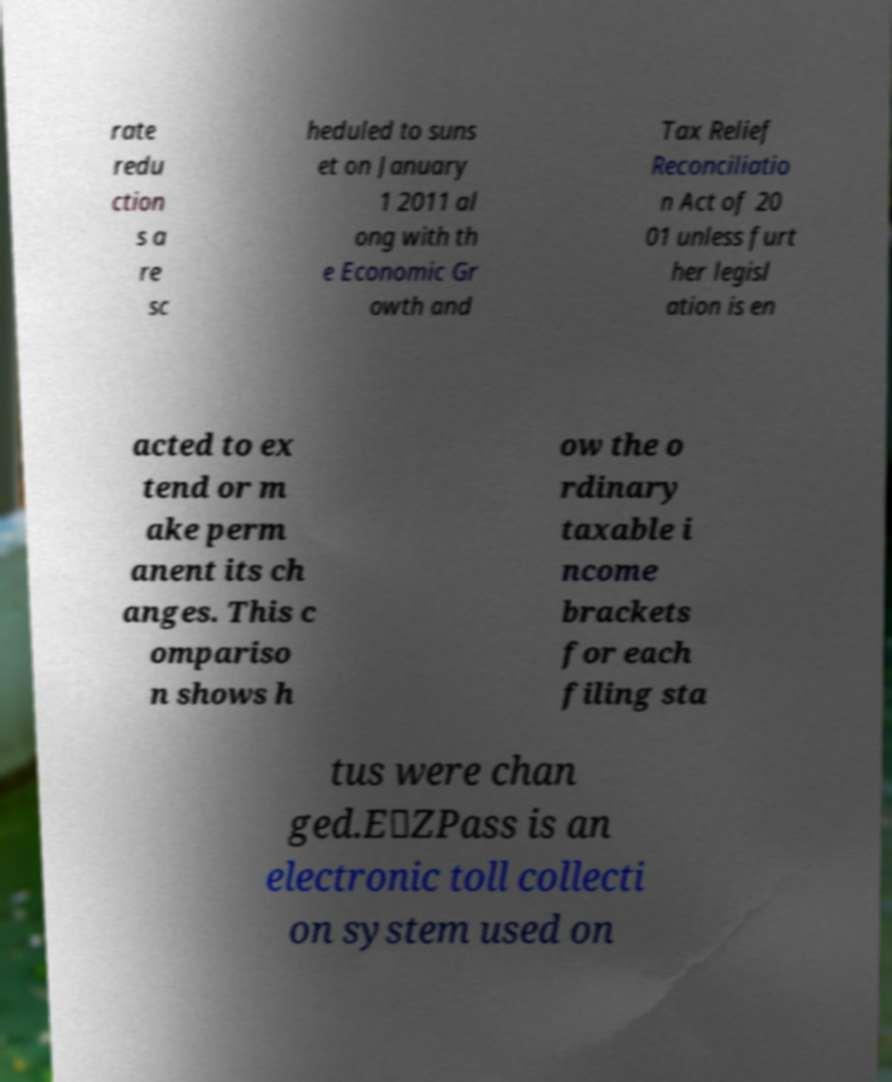Could you extract and type out the text from this image? rate redu ction s a re sc heduled to suns et on January 1 2011 al ong with th e Economic Gr owth and Tax Relief Reconciliatio n Act of 20 01 unless furt her legisl ation is en acted to ex tend or m ake perm anent its ch anges. This c ompariso n shows h ow the o rdinary taxable i ncome brackets for each filing sta tus were chan ged.E‑ZPass is an electronic toll collecti on system used on 